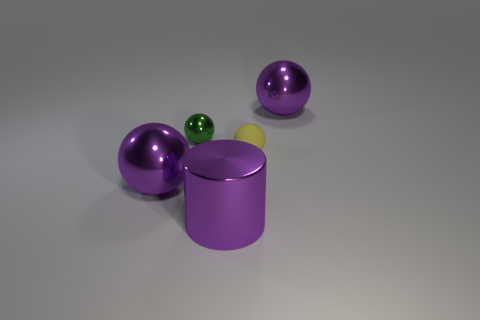Is there anything else that has the same material as the yellow object?
Your response must be concise. No. Does the purple metal thing that is right of the yellow matte ball have the same size as the green metal thing on the left side of the small yellow ball?
Provide a succinct answer. No. What size is the purple metal sphere that is to the right of the big purple ball on the left side of the purple shiny cylinder?
Your response must be concise. Large. There is a purple thing that is both to the right of the tiny metallic object and on the left side of the small rubber object; what material is it?
Offer a terse response. Metal. The metallic cylinder has what color?
Your answer should be very brief. Purple. The tiny thing that is on the left side of the cylinder has what shape?
Provide a succinct answer. Sphere. Are there any rubber spheres behind the shiny sphere left of the small green metallic ball that is behind the small rubber thing?
Give a very brief answer. Yes. Is there anything else that has the same shape as the green object?
Offer a very short reply. Yes. Is there a big brown metallic block?
Keep it short and to the point. No. Do the purple cylinder on the left side of the matte object and the large purple sphere right of the big metal cylinder have the same material?
Keep it short and to the point. Yes. 